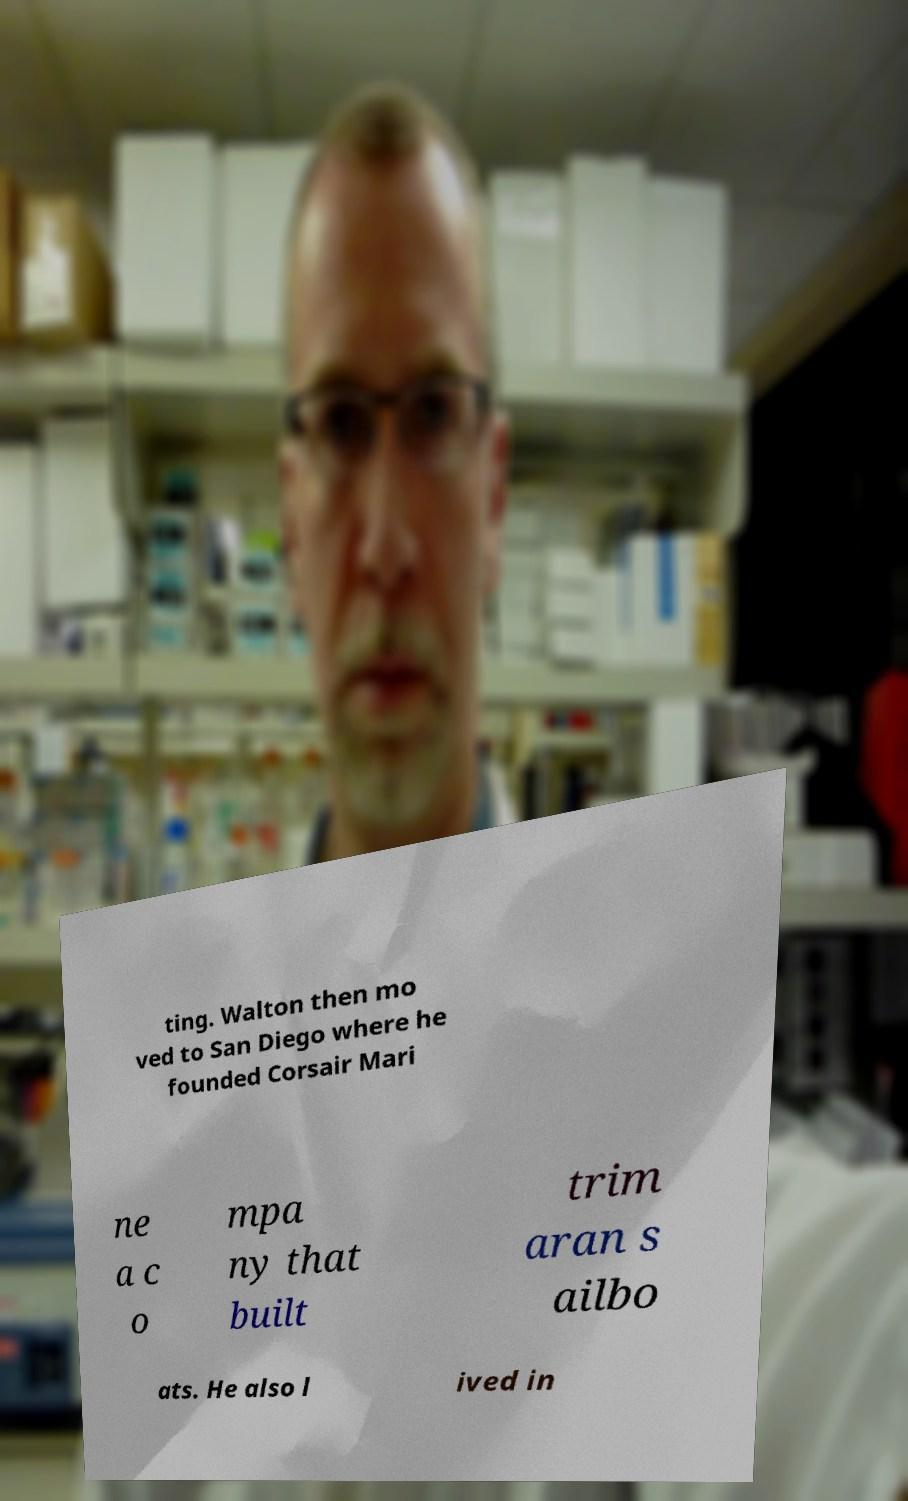For documentation purposes, I need the text within this image transcribed. Could you provide that? ting. Walton then mo ved to San Diego where he founded Corsair Mari ne a c o mpa ny that built trim aran s ailbo ats. He also l ived in 